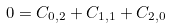<formula> <loc_0><loc_0><loc_500><loc_500>0 = C _ { 0 , 2 } + C _ { 1 , 1 } + C _ { 2 , 0 }</formula> 